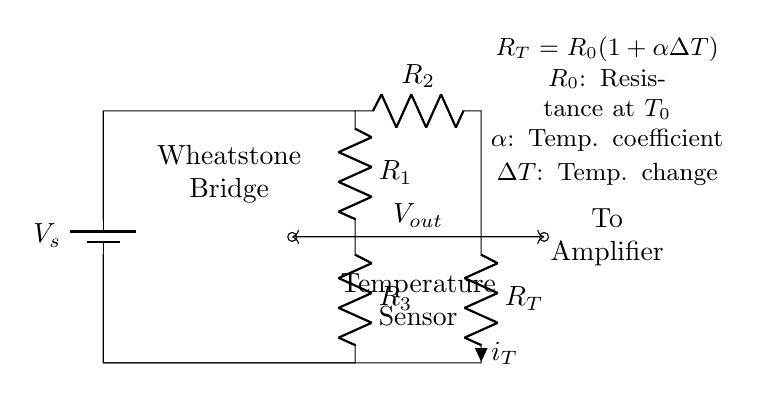What is the type of circuit shown? The circuit is a Wheatstone bridge, which is a device used for measuring electrical resistance by balancing two legs of a bridge circuit.
Answer: Wheatstone bridge What components are used in the bridge circuit? The circuit includes four resistors (R1, R2, R3, and RT), a battery (Vs), and is connected to an amplifier.
Answer: Four resistors, a battery, amplifier What does RT represent in the circuit? RT represents the resistance of the temperature sensor, which changes based on the temperature measured.
Answer: Resistance of the temperature sensor What is the output voltage denoted by? The output voltage is denoted by Vout, which is the voltage difference between the points connecting the resistors R2 and R3.
Answer: Vout Which component's resistance changes with temperature? The resistance that changes with temperature is RT (the temperature sensor), as indicated by the equation provided in the circuit.
Answer: RT What does the equation R_T = R_0(1 + αΔT) signify? This equation indicates that RT varies with the reference resistance R0, the temperature coefficient α, and the change in temperature ΔT.
Answer: Temperature dependence of RT What is the role of the amplifier in this circuit? The amplifier is used to amplify the output voltage Vout for more precise measurements, making it easier to analyze temperature changes.
Answer: To amplify the output voltage 